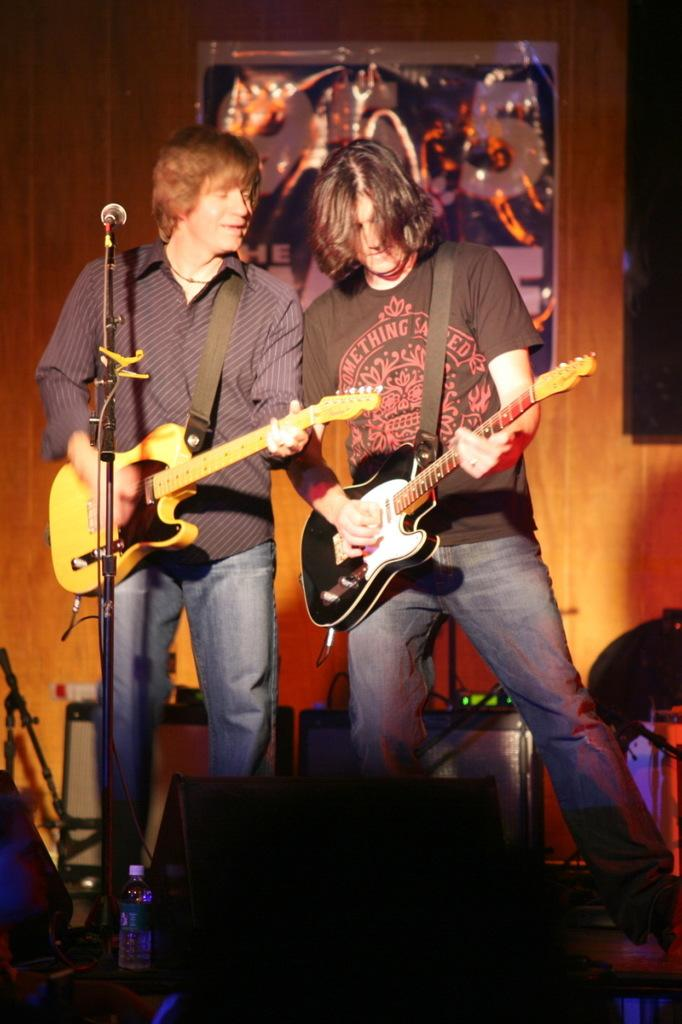How many people are in the image? There are two men in the image. What are the men doing in the image? The men are standing on a stage and playing guitars. What are the men holding in their hands? The men are holding microphones. What other equipment can be seen in the image? There is a mic stand in the image. What is visible in the background of the image? There is a wall in the background of the image. What type of structure is the men kicking in the image? There is no structure present in the image, nor are the men kicking anything. 